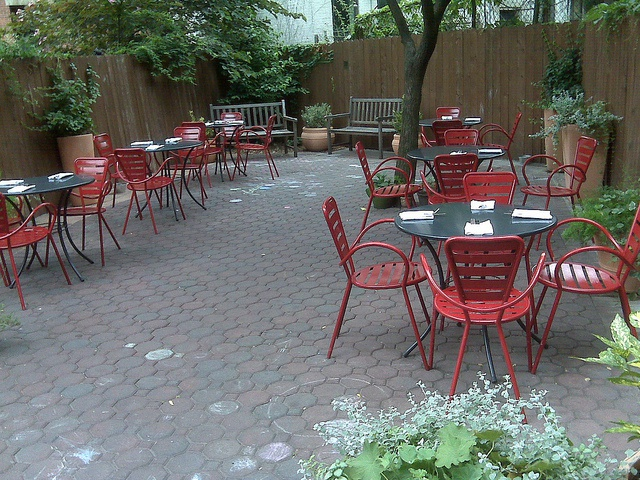Describe the objects in this image and their specific colors. I can see potted plant in gray, darkgray, lightgreen, and lightblue tones, chair in gray, black, maroon, and darkgray tones, chair in gray, maroon, and brown tones, chair in gray, maroon, and brown tones, and chair in gray, maroon, and brown tones in this image. 